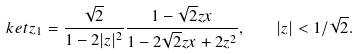Convert formula to latex. <formula><loc_0><loc_0><loc_500><loc_500>\ k e t { z } _ { 1 } = \frac { \sqrt { 2 } } { 1 - 2 | z | ^ { 2 } } \frac { 1 - \sqrt { 2 } z x } { 1 - 2 \sqrt { 2 } z x + 2 z ^ { 2 } } , \quad | z | < 1 / \sqrt { 2 } .</formula> 